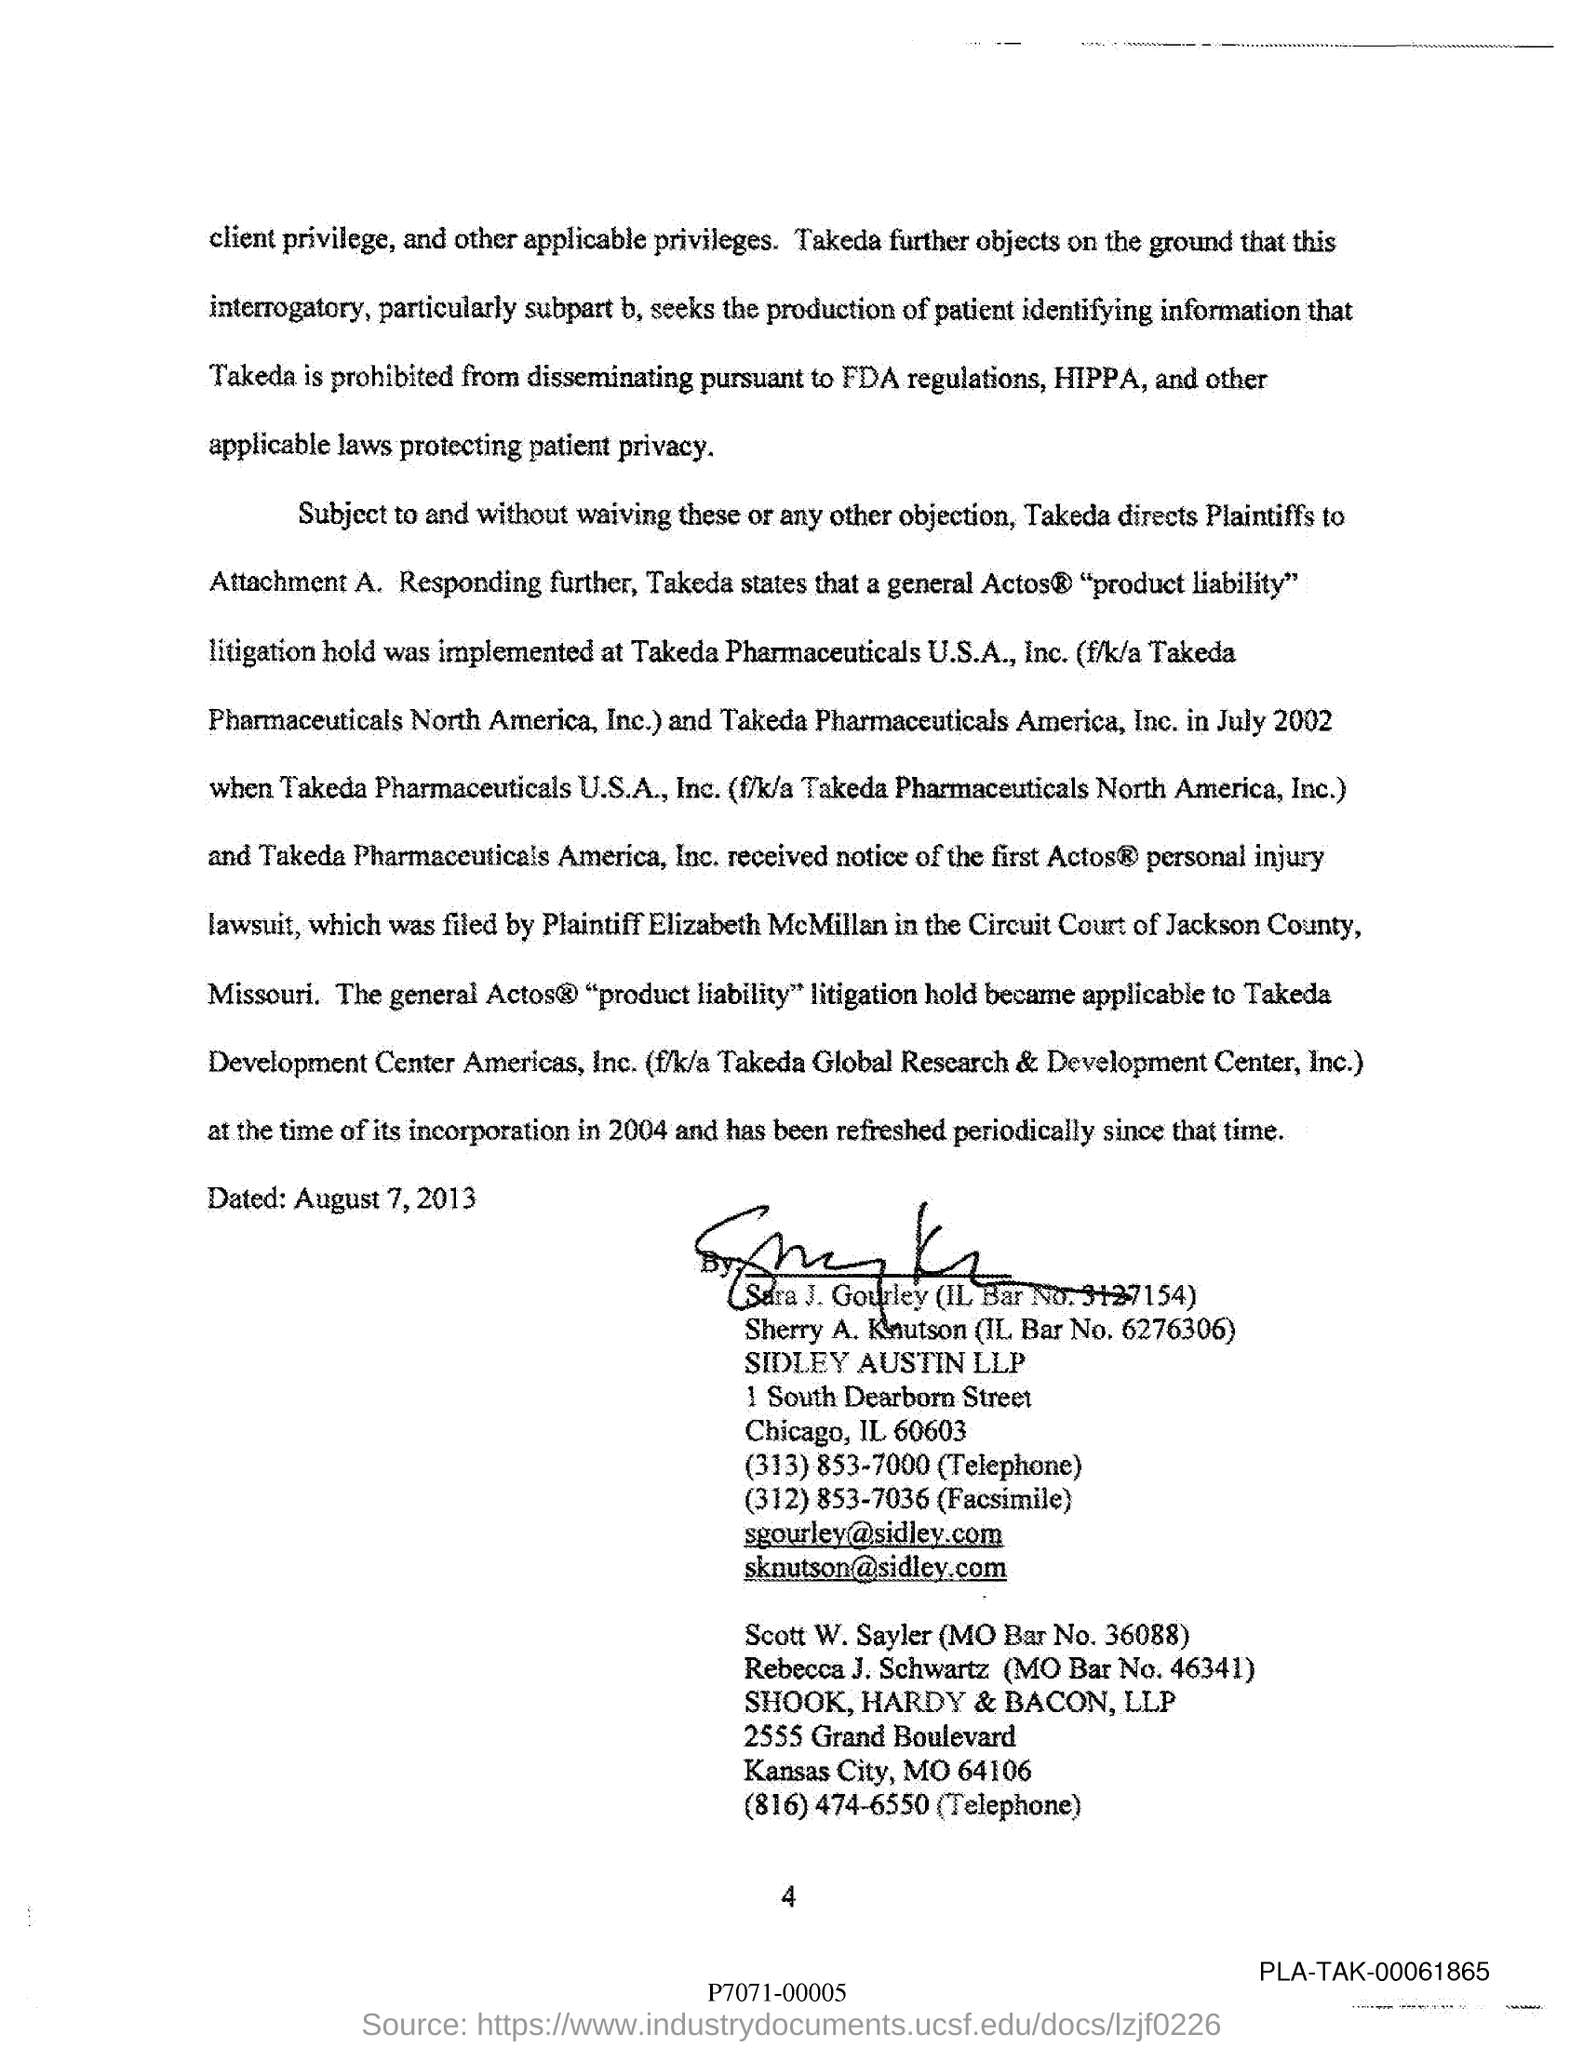What is the MO Bar No. of Scott W. Sayler?
 36088 